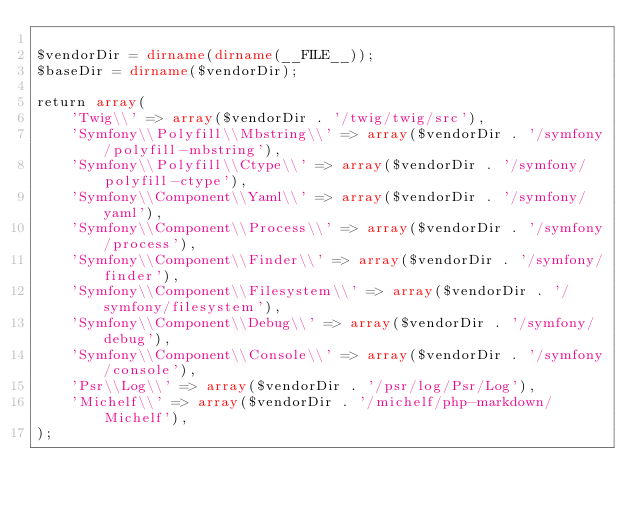<code> <loc_0><loc_0><loc_500><loc_500><_PHP_>
$vendorDir = dirname(dirname(__FILE__));
$baseDir = dirname($vendorDir);

return array(
    'Twig\\' => array($vendorDir . '/twig/twig/src'),
    'Symfony\\Polyfill\\Mbstring\\' => array($vendorDir . '/symfony/polyfill-mbstring'),
    'Symfony\\Polyfill\\Ctype\\' => array($vendorDir . '/symfony/polyfill-ctype'),
    'Symfony\\Component\\Yaml\\' => array($vendorDir . '/symfony/yaml'),
    'Symfony\\Component\\Process\\' => array($vendorDir . '/symfony/process'),
    'Symfony\\Component\\Finder\\' => array($vendorDir . '/symfony/finder'),
    'Symfony\\Component\\Filesystem\\' => array($vendorDir . '/symfony/filesystem'),
    'Symfony\\Component\\Debug\\' => array($vendorDir . '/symfony/debug'),
    'Symfony\\Component\\Console\\' => array($vendorDir . '/symfony/console'),
    'Psr\\Log\\' => array($vendorDir . '/psr/log/Psr/Log'),
    'Michelf\\' => array($vendorDir . '/michelf/php-markdown/Michelf'),
);
</code> 